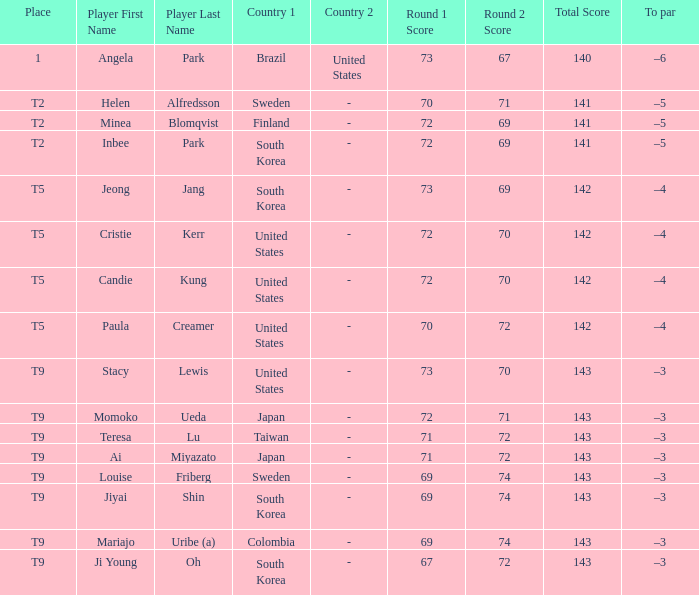Which country placed t9 and had the player jiyai shin? South Korea. 